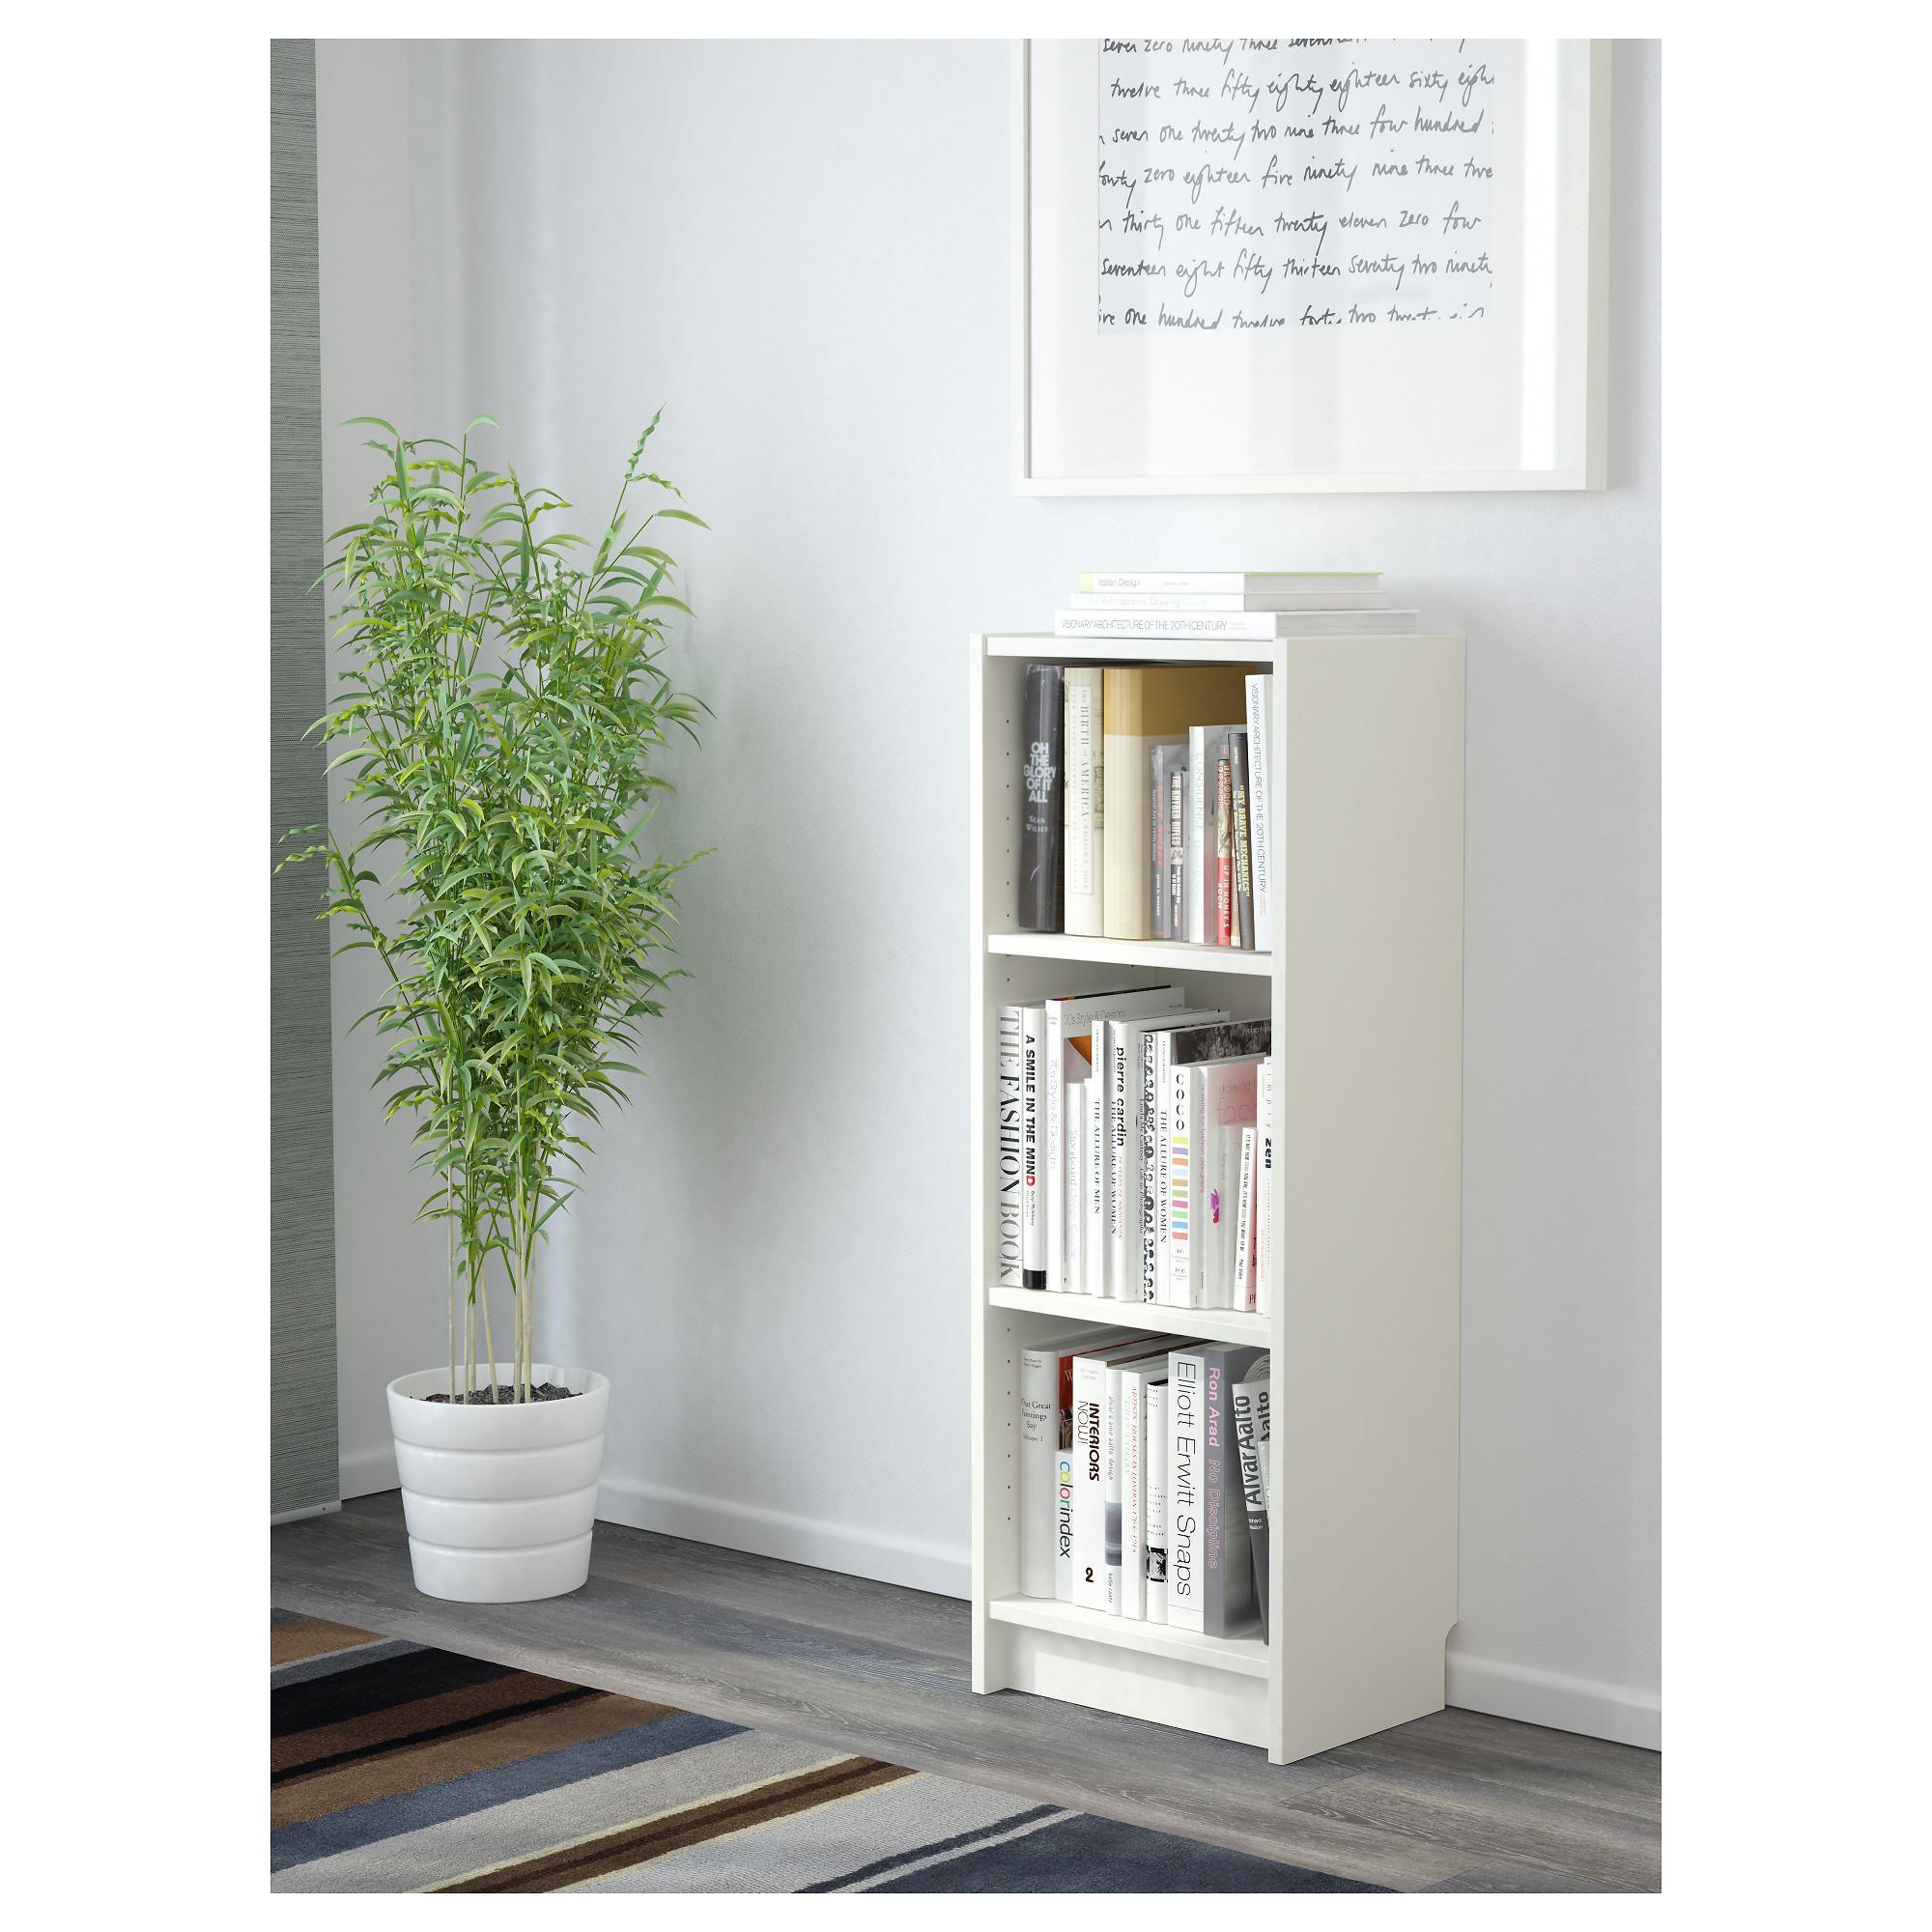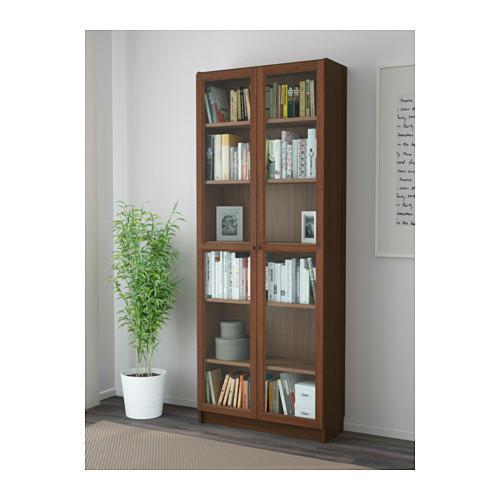The first image is the image on the left, the second image is the image on the right. Given the left and right images, does the statement "The left image contains a bookshelf that is not white." hold true? Answer yes or no. No. 